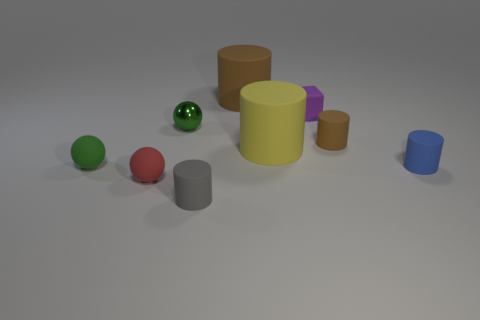How many purple rubber cubes are right of the ball that is behind the big yellow matte thing?
Your answer should be compact. 1. What size is the green sphere left of the rubber ball right of the sphere that is to the left of the red rubber sphere?
Your answer should be very brief. Small. What color is the small cylinder that is on the left side of the brown cylinder in front of the purple matte thing?
Offer a very short reply. Gray. What number of other objects are the same material as the purple block?
Make the answer very short. 7. How many other things are the same color as the small metallic thing?
Give a very brief answer. 1. The brown cylinder that is in front of the brown rubber thing that is left of the small rubber cube is made of what material?
Provide a succinct answer. Rubber. Is there a large red rubber sphere?
Keep it short and to the point. No. What size is the brown matte cylinder in front of the small ball that is behind the small green rubber ball?
Your answer should be compact. Small. Is the number of metal balls in front of the small green rubber object greater than the number of tiny gray cylinders that are behind the small red object?
Offer a terse response. No. How many blocks are big cyan metal objects or big yellow objects?
Your answer should be compact. 0. 